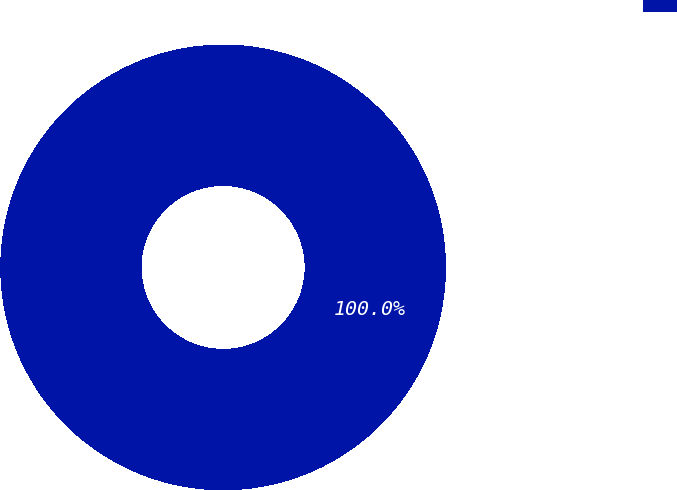<chart> <loc_0><loc_0><loc_500><loc_500><pie_chart><ecel><nl><fcel>100.0%<nl></chart> 